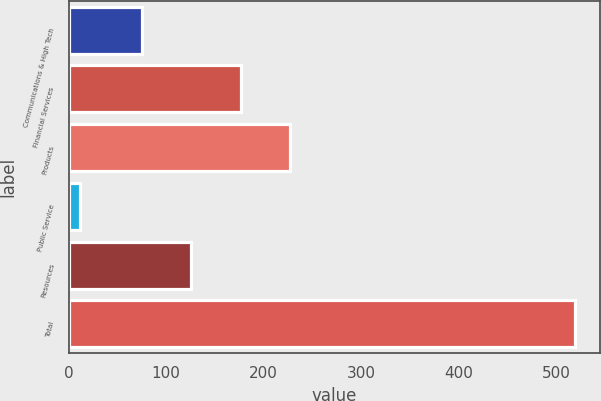Convert chart. <chart><loc_0><loc_0><loc_500><loc_500><bar_chart><fcel>Communications & High Tech<fcel>Financial Services<fcel>Products<fcel>Public Service<fcel>Resources<fcel>Total<nl><fcel>75<fcel>176.4<fcel>227.1<fcel>12<fcel>125.7<fcel>519<nl></chart> 